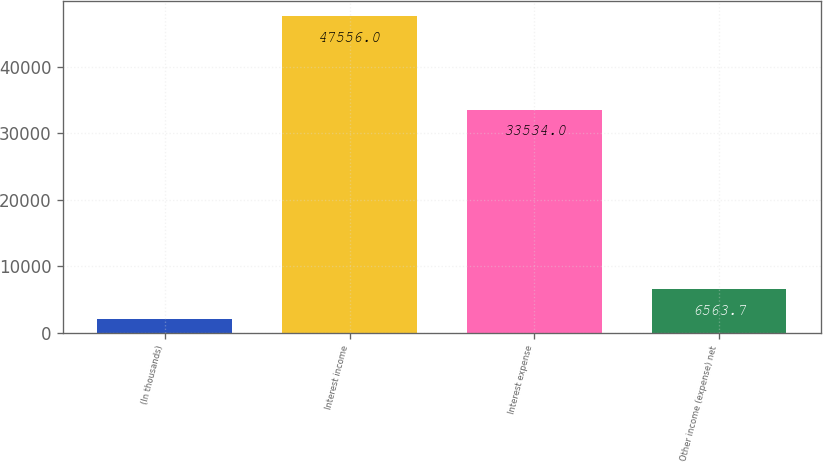Convert chart. <chart><loc_0><loc_0><loc_500><loc_500><bar_chart><fcel>(In thousands)<fcel>Interest income<fcel>Interest expense<fcel>Other income (expense) net<nl><fcel>2009<fcel>47556<fcel>33534<fcel>6563.7<nl></chart> 